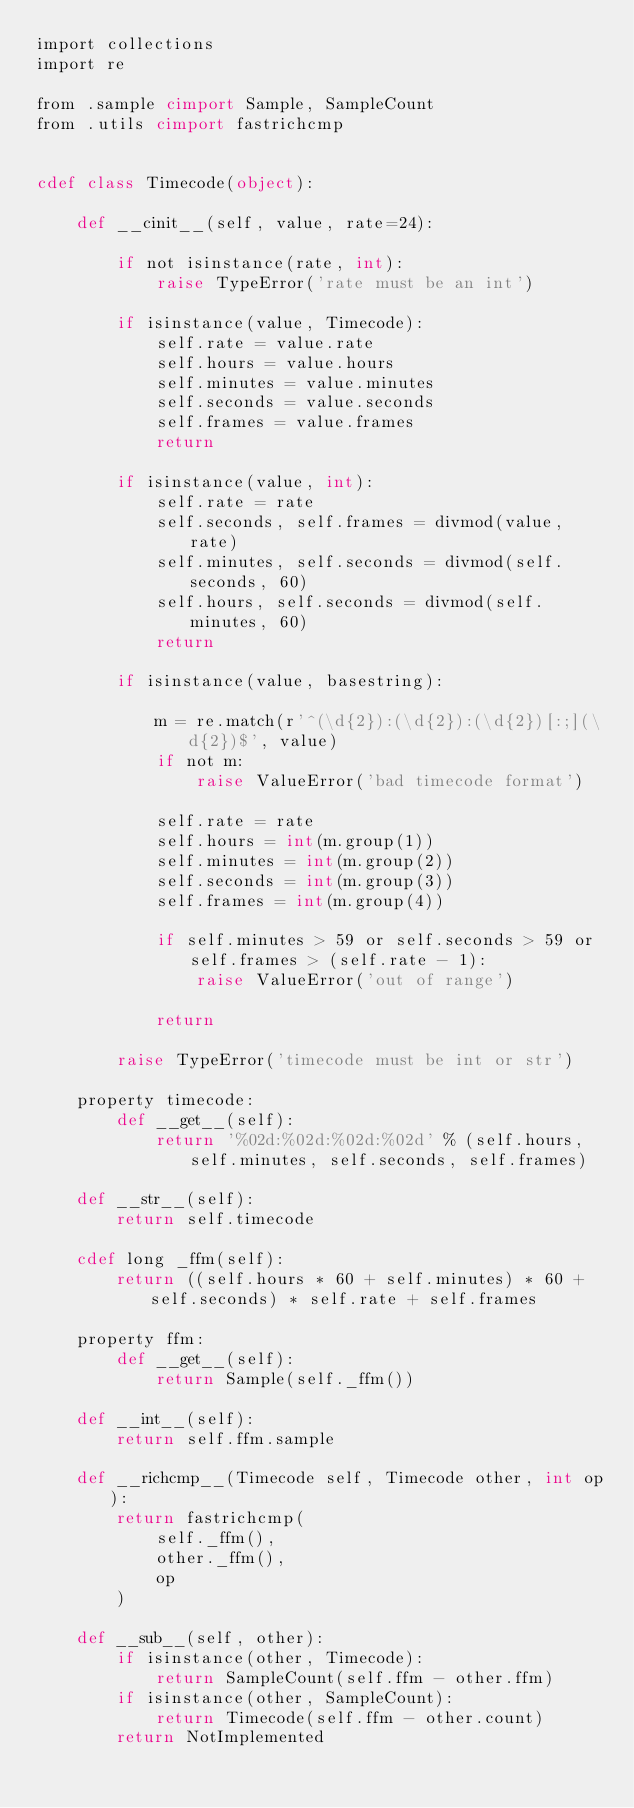<code> <loc_0><loc_0><loc_500><loc_500><_Cython_>import collections
import re

from .sample cimport Sample, SampleCount
from .utils cimport fastrichcmp


cdef class Timecode(object):

    def __cinit__(self, value, rate=24):

        if not isinstance(rate, int):
            raise TypeError('rate must be an int')
        
        if isinstance(value, Timecode):
            self.rate = value.rate
            self.hours = value.hours
            self.minutes = value.minutes
            self.seconds = value.seconds
            self.frames = value.frames
            return

        if isinstance(value, int):
            self.rate = rate
            self.seconds, self.frames = divmod(value, rate)
            self.minutes, self.seconds = divmod(self.seconds, 60)
            self.hours, self.seconds = divmod(self.minutes, 60)
            return

        if isinstance(value, basestring):

            m = re.match(r'^(\d{2}):(\d{2}):(\d{2})[:;](\d{2})$', value)
            if not m:
                raise ValueError('bad timecode format')

            self.rate = rate
            self.hours = int(m.group(1))
            self.minutes = int(m.group(2))
            self.seconds = int(m.group(3))
            self.frames = int(m.group(4))

            if self.minutes > 59 or self.seconds > 59 or self.frames > (self.rate - 1):
                raise ValueError('out of range')

            return

        raise TypeError('timecode must be int or str')

    property timecode:
        def __get__(self):
            return '%02d:%02d:%02d:%02d' % (self.hours, self.minutes, self.seconds, self.frames)

    def __str__(self):
        return self.timecode

    cdef long _ffm(self):
        return ((self.hours * 60 + self.minutes) * 60 + self.seconds) * self.rate + self.frames

    property ffm:
        def __get__(self):
            return Sample(self._ffm())

    def __int__(self):
        return self.ffm.sample

    def __richcmp__(Timecode self, Timecode other, int op):
        return fastrichcmp(
            self._ffm(),
            other._ffm(),
            op
        )

    def __sub__(self, other):
        if isinstance(other, Timecode):
            return SampleCount(self.ffm - other.ffm)
        if isinstance(other, SampleCount):
            return Timecode(self.ffm - other.count)
        return NotImplemented



</code> 